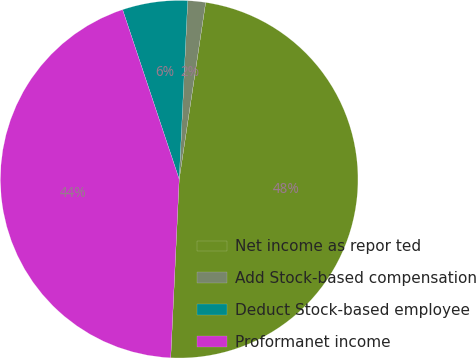Convert chart to OTSL. <chart><loc_0><loc_0><loc_500><loc_500><pie_chart><fcel>Net income as repor ted<fcel>Add Stock-based compensation<fcel>Deduct Stock-based employee<fcel>Proformanet income<nl><fcel>48.39%<fcel>1.61%<fcel>5.88%<fcel>44.12%<nl></chart> 